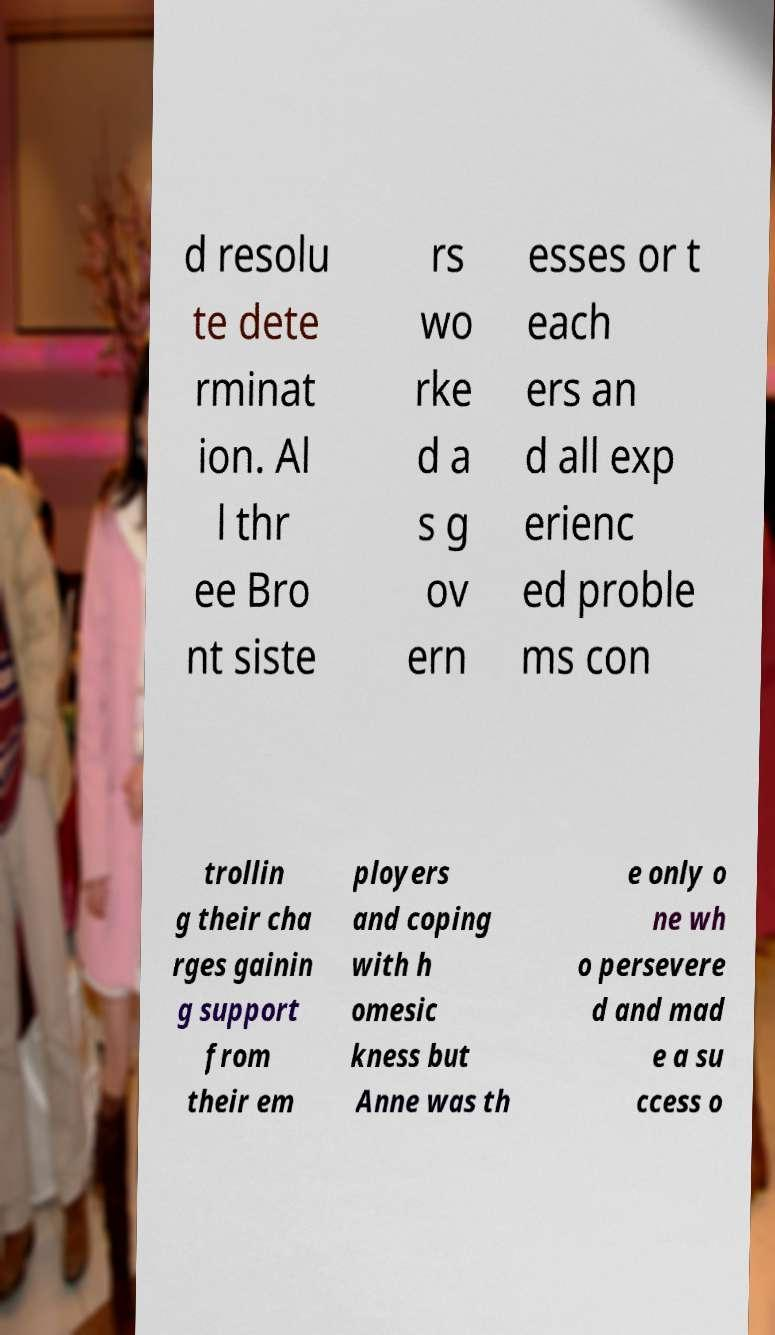I need the written content from this picture converted into text. Can you do that? d resolu te dete rminat ion. Al l thr ee Bro nt siste rs wo rke d a s g ov ern esses or t each ers an d all exp erienc ed proble ms con trollin g their cha rges gainin g support from their em ployers and coping with h omesic kness but Anne was th e only o ne wh o persevere d and mad e a su ccess o 